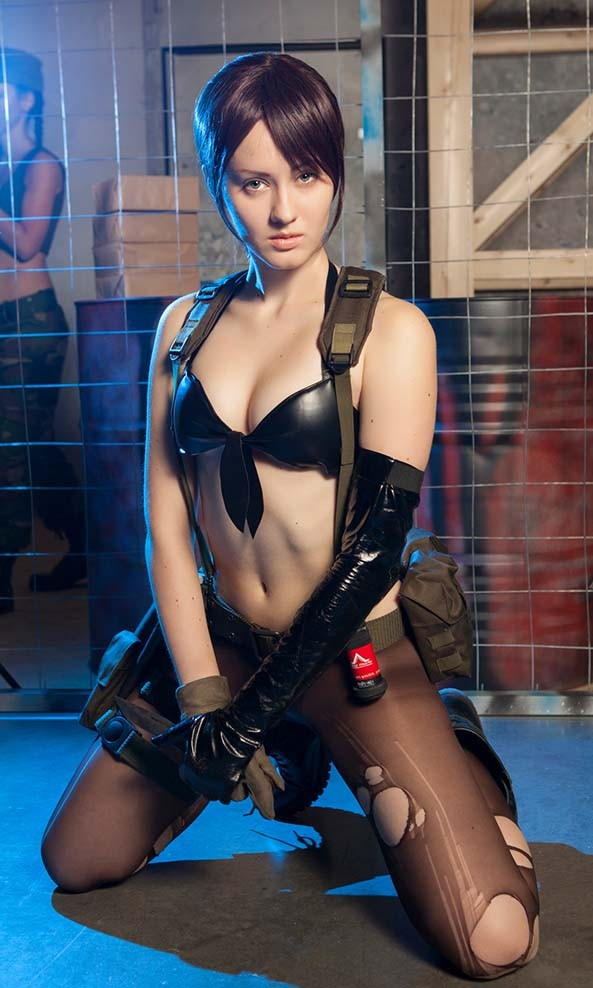How does the environment in the background contribute to the character's story or setting? The industrial and somewhat dilapidated background offers a stark contrast to the character, emphasizing a sense of resilience or adversity. It could imply a post-apocalyptic or urban dystopian setting, where the character thrives against the odds. The harshness of their environment likely shapes the character's skills and mental fortitude, suggesting a backstory involving survival or combat in challenging circumstances. 